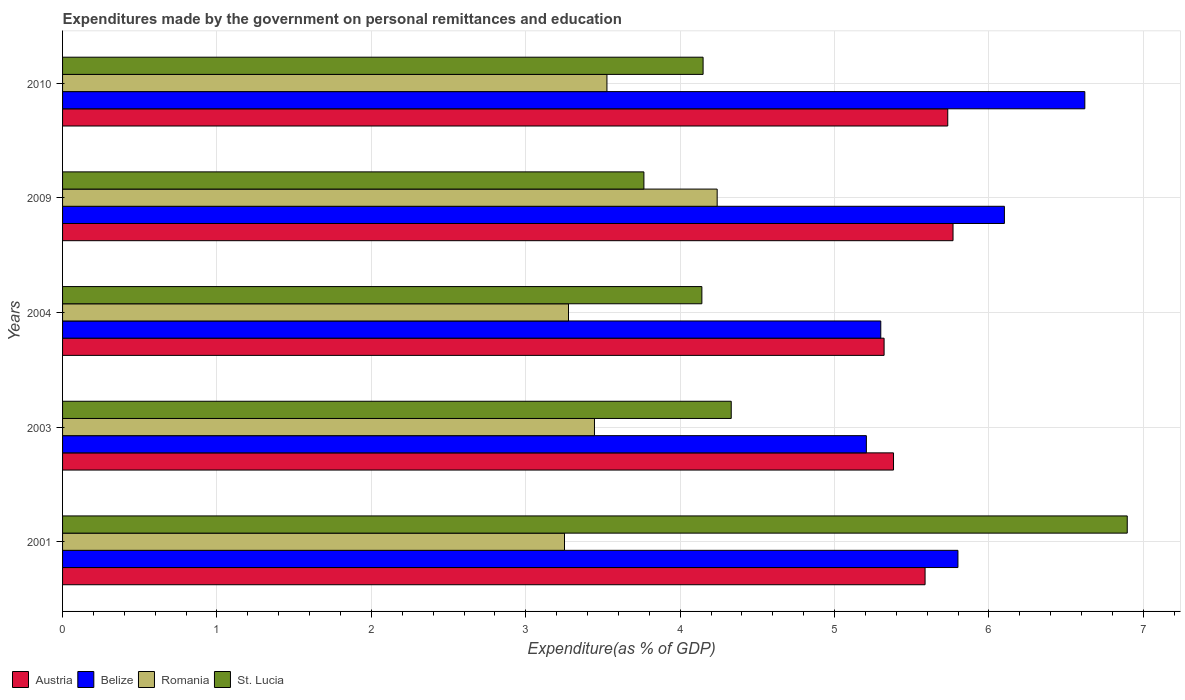How many groups of bars are there?
Make the answer very short. 5. Are the number of bars per tick equal to the number of legend labels?
Your answer should be very brief. Yes. How many bars are there on the 1st tick from the top?
Offer a terse response. 4. In how many cases, is the number of bars for a given year not equal to the number of legend labels?
Give a very brief answer. 0. What is the expenditures made by the government on personal remittances and education in Austria in 2010?
Ensure brevity in your answer.  5.73. Across all years, what is the maximum expenditures made by the government on personal remittances and education in St. Lucia?
Provide a short and direct response. 6.9. Across all years, what is the minimum expenditures made by the government on personal remittances and education in Romania?
Offer a terse response. 3.25. In which year was the expenditures made by the government on personal remittances and education in St. Lucia maximum?
Ensure brevity in your answer.  2001. What is the total expenditures made by the government on personal remittances and education in St. Lucia in the graph?
Keep it short and to the point. 23.28. What is the difference between the expenditures made by the government on personal remittances and education in Romania in 2004 and that in 2010?
Make the answer very short. -0.25. What is the difference between the expenditures made by the government on personal remittances and education in Austria in 2009 and the expenditures made by the government on personal remittances and education in Romania in 2001?
Offer a terse response. 2.52. What is the average expenditures made by the government on personal remittances and education in Romania per year?
Ensure brevity in your answer.  3.55. In the year 2001, what is the difference between the expenditures made by the government on personal remittances and education in Belize and expenditures made by the government on personal remittances and education in Romania?
Your response must be concise. 2.55. In how many years, is the expenditures made by the government on personal remittances and education in Belize greater than 1.6 %?
Offer a terse response. 5. What is the ratio of the expenditures made by the government on personal remittances and education in Belize in 2001 to that in 2003?
Your answer should be compact. 1.11. Is the difference between the expenditures made by the government on personal remittances and education in Belize in 2001 and 2009 greater than the difference between the expenditures made by the government on personal remittances and education in Romania in 2001 and 2009?
Make the answer very short. Yes. What is the difference between the highest and the second highest expenditures made by the government on personal remittances and education in St. Lucia?
Your answer should be compact. 2.56. What is the difference between the highest and the lowest expenditures made by the government on personal remittances and education in St. Lucia?
Give a very brief answer. 3.13. What does the 1st bar from the bottom in 2001 represents?
Your answer should be compact. Austria. Is it the case that in every year, the sum of the expenditures made by the government on personal remittances and education in Belize and expenditures made by the government on personal remittances and education in Romania is greater than the expenditures made by the government on personal remittances and education in Austria?
Your response must be concise. Yes. How many years are there in the graph?
Offer a terse response. 5. Are the values on the major ticks of X-axis written in scientific E-notation?
Give a very brief answer. No. Does the graph contain any zero values?
Keep it short and to the point. No. Does the graph contain grids?
Keep it short and to the point. Yes. How many legend labels are there?
Keep it short and to the point. 4. How are the legend labels stacked?
Your answer should be compact. Horizontal. What is the title of the graph?
Provide a succinct answer. Expenditures made by the government on personal remittances and education. Does "Luxembourg" appear as one of the legend labels in the graph?
Provide a succinct answer. No. What is the label or title of the X-axis?
Give a very brief answer. Expenditure(as % of GDP). What is the Expenditure(as % of GDP) in Austria in 2001?
Your answer should be compact. 5.59. What is the Expenditure(as % of GDP) in Belize in 2001?
Make the answer very short. 5.8. What is the Expenditure(as % of GDP) in Romania in 2001?
Your answer should be compact. 3.25. What is the Expenditure(as % of GDP) in St. Lucia in 2001?
Offer a very short reply. 6.9. What is the Expenditure(as % of GDP) in Austria in 2003?
Offer a terse response. 5.38. What is the Expenditure(as % of GDP) of Belize in 2003?
Provide a succinct answer. 5.21. What is the Expenditure(as % of GDP) of Romania in 2003?
Offer a very short reply. 3.45. What is the Expenditure(as % of GDP) of St. Lucia in 2003?
Offer a very short reply. 4.33. What is the Expenditure(as % of GDP) in Austria in 2004?
Offer a terse response. 5.32. What is the Expenditure(as % of GDP) in Belize in 2004?
Offer a very short reply. 5.3. What is the Expenditure(as % of GDP) of Romania in 2004?
Offer a terse response. 3.28. What is the Expenditure(as % of GDP) in St. Lucia in 2004?
Provide a short and direct response. 4.14. What is the Expenditure(as % of GDP) of Austria in 2009?
Provide a short and direct response. 5.77. What is the Expenditure(as % of GDP) of Belize in 2009?
Your response must be concise. 6.1. What is the Expenditure(as % of GDP) of Romania in 2009?
Ensure brevity in your answer.  4.24. What is the Expenditure(as % of GDP) in St. Lucia in 2009?
Provide a succinct answer. 3.77. What is the Expenditure(as % of GDP) in Austria in 2010?
Give a very brief answer. 5.73. What is the Expenditure(as % of GDP) in Belize in 2010?
Give a very brief answer. 6.62. What is the Expenditure(as % of GDP) of Romania in 2010?
Offer a very short reply. 3.53. What is the Expenditure(as % of GDP) of St. Lucia in 2010?
Give a very brief answer. 4.15. Across all years, what is the maximum Expenditure(as % of GDP) of Austria?
Offer a very short reply. 5.77. Across all years, what is the maximum Expenditure(as % of GDP) of Belize?
Provide a succinct answer. 6.62. Across all years, what is the maximum Expenditure(as % of GDP) in Romania?
Provide a short and direct response. 4.24. Across all years, what is the maximum Expenditure(as % of GDP) of St. Lucia?
Keep it short and to the point. 6.9. Across all years, what is the minimum Expenditure(as % of GDP) of Austria?
Your answer should be compact. 5.32. Across all years, what is the minimum Expenditure(as % of GDP) of Belize?
Keep it short and to the point. 5.21. Across all years, what is the minimum Expenditure(as % of GDP) in Romania?
Provide a succinct answer. 3.25. Across all years, what is the minimum Expenditure(as % of GDP) of St. Lucia?
Keep it short and to the point. 3.77. What is the total Expenditure(as % of GDP) of Austria in the graph?
Your answer should be compact. 27.79. What is the total Expenditure(as % of GDP) of Belize in the graph?
Make the answer very short. 29.03. What is the total Expenditure(as % of GDP) in Romania in the graph?
Your answer should be very brief. 17.74. What is the total Expenditure(as % of GDP) of St. Lucia in the graph?
Your response must be concise. 23.28. What is the difference between the Expenditure(as % of GDP) of Austria in 2001 and that in 2003?
Offer a very short reply. 0.2. What is the difference between the Expenditure(as % of GDP) of Belize in 2001 and that in 2003?
Offer a terse response. 0.59. What is the difference between the Expenditure(as % of GDP) of Romania in 2001 and that in 2003?
Offer a terse response. -0.19. What is the difference between the Expenditure(as % of GDP) in St. Lucia in 2001 and that in 2003?
Offer a terse response. 2.56. What is the difference between the Expenditure(as % of GDP) of Austria in 2001 and that in 2004?
Your answer should be compact. 0.27. What is the difference between the Expenditure(as % of GDP) in Belize in 2001 and that in 2004?
Keep it short and to the point. 0.5. What is the difference between the Expenditure(as % of GDP) of Romania in 2001 and that in 2004?
Your answer should be very brief. -0.03. What is the difference between the Expenditure(as % of GDP) of St. Lucia in 2001 and that in 2004?
Ensure brevity in your answer.  2.76. What is the difference between the Expenditure(as % of GDP) in Austria in 2001 and that in 2009?
Give a very brief answer. -0.18. What is the difference between the Expenditure(as % of GDP) of Belize in 2001 and that in 2009?
Your response must be concise. -0.3. What is the difference between the Expenditure(as % of GDP) of Romania in 2001 and that in 2009?
Offer a terse response. -0.99. What is the difference between the Expenditure(as % of GDP) in St. Lucia in 2001 and that in 2009?
Provide a succinct answer. 3.13. What is the difference between the Expenditure(as % of GDP) of Austria in 2001 and that in 2010?
Provide a succinct answer. -0.15. What is the difference between the Expenditure(as % of GDP) in Belize in 2001 and that in 2010?
Provide a succinct answer. -0.82. What is the difference between the Expenditure(as % of GDP) in Romania in 2001 and that in 2010?
Make the answer very short. -0.27. What is the difference between the Expenditure(as % of GDP) of St. Lucia in 2001 and that in 2010?
Offer a terse response. 2.75. What is the difference between the Expenditure(as % of GDP) in Austria in 2003 and that in 2004?
Give a very brief answer. 0.06. What is the difference between the Expenditure(as % of GDP) in Belize in 2003 and that in 2004?
Offer a very short reply. -0.09. What is the difference between the Expenditure(as % of GDP) of Romania in 2003 and that in 2004?
Give a very brief answer. 0.17. What is the difference between the Expenditure(as % of GDP) in St. Lucia in 2003 and that in 2004?
Offer a very short reply. 0.19. What is the difference between the Expenditure(as % of GDP) in Austria in 2003 and that in 2009?
Offer a very short reply. -0.39. What is the difference between the Expenditure(as % of GDP) of Belize in 2003 and that in 2009?
Your answer should be compact. -0.89. What is the difference between the Expenditure(as % of GDP) of Romania in 2003 and that in 2009?
Keep it short and to the point. -0.79. What is the difference between the Expenditure(as % of GDP) in St. Lucia in 2003 and that in 2009?
Your response must be concise. 0.57. What is the difference between the Expenditure(as % of GDP) of Austria in 2003 and that in 2010?
Give a very brief answer. -0.35. What is the difference between the Expenditure(as % of GDP) of Belize in 2003 and that in 2010?
Provide a short and direct response. -1.41. What is the difference between the Expenditure(as % of GDP) in Romania in 2003 and that in 2010?
Offer a terse response. -0.08. What is the difference between the Expenditure(as % of GDP) of St. Lucia in 2003 and that in 2010?
Your response must be concise. 0.18. What is the difference between the Expenditure(as % of GDP) of Austria in 2004 and that in 2009?
Offer a terse response. -0.45. What is the difference between the Expenditure(as % of GDP) of Belize in 2004 and that in 2009?
Provide a short and direct response. -0.8. What is the difference between the Expenditure(as % of GDP) of Romania in 2004 and that in 2009?
Offer a very short reply. -0.96. What is the difference between the Expenditure(as % of GDP) in St. Lucia in 2004 and that in 2009?
Your answer should be very brief. 0.38. What is the difference between the Expenditure(as % of GDP) in Austria in 2004 and that in 2010?
Offer a very short reply. -0.41. What is the difference between the Expenditure(as % of GDP) of Belize in 2004 and that in 2010?
Provide a short and direct response. -1.32. What is the difference between the Expenditure(as % of GDP) in Romania in 2004 and that in 2010?
Offer a very short reply. -0.25. What is the difference between the Expenditure(as % of GDP) in St. Lucia in 2004 and that in 2010?
Make the answer very short. -0.01. What is the difference between the Expenditure(as % of GDP) in Austria in 2009 and that in 2010?
Provide a succinct answer. 0.03. What is the difference between the Expenditure(as % of GDP) of Belize in 2009 and that in 2010?
Ensure brevity in your answer.  -0.52. What is the difference between the Expenditure(as % of GDP) of Romania in 2009 and that in 2010?
Your response must be concise. 0.71. What is the difference between the Expenditure(as % of GDP) in St. Lucia in 2009 and that in 2010?
Keep it short and to the point. -0.38. What is the difference between the Expenditure(as % of GDP) of Austria in 2001 and the Expenditure(as % of GDP) of Belize in 2003?
Keep it short and to the point. 0.38. What is the difference between the Expenditure(as % of GDP) in Austria in 2001 and the Expenditure(as % of GDP) in Romania in 2003?
Ensure brevity in your answer.  2.14. What is the difference between the Expenditure(as % of GDP) of Austria in 2001 and the Expenditure(as % of GDP) of St. Lucia in 2003?
Keep it short and to the point. 1.26. What is the difference between the Expenditure(as % of GDP) of Belize in 2001 and the Expenditure(as % of GDP) of Romania in 2003?
Offer a terse response. 2.35. What is the difference between the Expenditure(as % of GDP) in Belize in 2001 and the Expenditure(as % of GDP) in St. Lucia in 2003?
Provide a short and direct response. 1.47. What is the difference between the Expenditure(as % of GDP) of Romania in 2001 and the Expenditure(as % of GDP) of St. Lucia in 2003?
Make the answer very short. -1.08. What is the difference between the Expenditure(as % of GDP) of Austria in 2001 and the Expenditure(as % of GDP) of Belize in 2004?
Give a very brief answer. 0.29. What is the difference between the Expenditure(as % of GDP) of Austria in 2001 and the Expenditure(as % of GDP) of Romania in 2004?
Keep it short and to the point. 2.31. What is the difference between the Expenditure(as % of GDP) of Austria in 2001 and the Expenditure(as % of GDP) of St. Lucia in 2004?
Your answer should be very brief. 1.45. What is the difference between the Expenditure(as % of GDP) of Belize in 2001 and the Expenditure(as % of GDP) of Romania in 2004?
Your answer should be compact. 2.52. What is the difference between the Expenditure(as % of GDP) in Belize in 2001 and the Expenditure(as % of GDP) in St. Lucia in 2004?
Your answer should be very brief. 1.66. What is the difference between the Expenditure(as % of GDP) in Romania in 2001 and the Expenditure(as % of GDP) in St. Lucia in 2004?
Make the answer very short. -0.89. What is the difference between the Expenditure(as % of GDP) in Austria in 2001 and the Expenditure(as % of GDP) in Belize in 2009?
Ensure brevity in your answer.  -0.51. What is the difference between the Expenditure(as % of GDP) in Austria in 2001 and the Expenditure(as % of GDP) in Romania in 2009?
Offer a terse response. 1.35. What is the difference between the Expenditure(as % of GDP) of Austria in 2001 and the Expenditure(as % of GDP) of St. Lucia in 2009?
Offer a terse response. 1.82. What is the difference between the Expenditure(as % of GDP) of Belize in 2001 and the Expenditure(as % of GDP) of Romania in 2009?
Your response must be concise. 1.56. What is the difference between the Expenditure(as % of GDP) of Belize in 2001 and the Expenditure(as % of GDP) of St. Lucia in 2009?
Provide a succinct answer. 2.03. What is the difference between the Expenditure(as % of GDP) in Romania in 2001 and the Expenditure(as % of GDP) in St. Lucia in 2009?
Keep it short and to the point. -0.51. What is the difference between the Expenditure(as % of GDP) in Austria in 2001 and the Expenditure(as % of GDP) in Belize in 2010?
Give a very brief answer. -1.03. What is the difference between the Expenditure(as % of GDP) of Austria in 2001 and the Expenditure(as % of GDP) of Romania in 2010?
Your response must be concise. 2.06. What is the difference between the Expenditure(as % of GDP) of Austria in 2001 and the Expenditure(as % of GDP) of St. Lucia in 2010?
Your answer should be very brief. 1.44. What is the difference between the Expenditure(as % of GDP) in Belize in 2001 and the Expenditure(as % of GDP) in Romania in 2010?
Your answer should be compact. 2.27. What is the difference between the Expenditure(as % of GDP) in Belize in 2001 and the Expenditure(as % of GDP) in St. Lucia in 2010?
Your answer should be very brief. 1.65. What is the difference between the Expenditure(as % of GDP) in Romania in 2001 and the Expenditure(as % of GDP) in St. Lucia in 2010?
Make the answer very short. -0.9. What is the difference between the Expenditure(as % of GDP) in Austria in 2003 and the Expenditure(as % of GDP) in Belize in 2004?
Offer a very short reply. 0.08. What is the difference between the Expenditure(as % of GDP) in Austria in 2003 and the Expenditure(as % of GDP) in Romania in 2004?
Your answer should be compact. 2.1. What is the difference between the Expenditure(as % of GDP) of Austria in 2003 and the Expenditure(as % of GDP) of St. Lucia in 2004?
Offer a very short reply. 1.24. What is the difference between the Expenditure(as % of GDP) of Belize in 2003 and the Expenditure(as % of GDP) of Romania in 2004?
Make the answer very short. 1.93. What is the difference between the Expenditure(as % of GDP) in Belize in 2003 and the Expenditure(as % of GDP) in St. Lucia in 2004?
Ensure brevity in your answer.  1.07. What is the difference between the Expenditure(as % of GDP) in Romania in 2003 and the Expenditure(as % of GDP) in St. Lucia in 2004?
Offer a very short reply. -0.7. What is the difference between the Expenditure(as % of GDP) in Austria in 2003 and the Expenditure(as % of GDP) in Belize in 2009?
Your answer should be very brief. -0.72. What is the difference between the Expenditure(as % of GDP) in Austria in 2003 and the Expenditure(as % of GDP) in Romania in 2009?
Offer a very short reply. 1.14. What is the difference between the Expenditure(as % of GDP) in Austria in 2003 and the Expenditure(as % of GDP) in St. Lucia in 2009?
Give a very brief answer. 1.62. What is the difference between the Expenditure(as % of GDP) of Belize in 2003 and the Expenditure(as % of GDP) of Romania in 2009?
Ensure brevity in your answer.  0.97. What is the difference between the Expenditure(as % of GDP) of Belize in 2003 and the Expenditure(as % of GDP) of St. Lucia in 2009?
Your answer should be compact. 1.44. What is the difference between the Expenditure(as % of GDP) in Romania in 2003 and the Expenditure(as % of GDP) in St. Lucia in 2009?
Ensure brevity in your answer.  -0.32. What is the difference between the Expenditure(as % of GDP) of Austria in 2003 and the Expenditure(as % of GDP) of Belize in 2010?
Give a very brief answer. -1.24. What is the difference between the Expenditure(as % of GDP) of Austria in 2003 and the Expenditure(as % of GDP) of Romania in 2010?
Make the answer very short. 1.86. What is the difference between the Expenditure(as % of GDP) in Austria in 2003 and the Expenditure(as % of GDP) in St. Lucia in 2010?
Make the answer very short. 1.23. What is the difference between the Expenditure(as % of GDP) in Belize in 2003 and the Expenditure(as % of GDP) in Romania in 2010?
Offer a very short reply. 1.68. What is the difference between the Expenditure(as % of GDP) of Belize in 2003 and the Expenditure(as % of GDP) of St. Lucia in 2010?
Provide a succinct answer. 1.06. What is the difference between the Expenditure(as % of GDP) of Romania in 2003 and the Expenditure(as % of GDP) of St. Lucia in 2010?
Your answer should be compact. -0.7. What is the difference between the Expenditure(as % of GDP) of Austria in 2004 and the Expenditure(as % of GDP) of Belize in 2009?
Your response must be concise. -0.78. What is the difference between the Expenditure(as % of GDP) of Austria in 2004 and the Expenditure(as % of GDP) of Romania in 2009?
Your answer should be compact. 1.08. What is the difference between the Expenditure(as % of GDP) of Austria in 2004 and the Expenditure(as % of GDP) of St. Lucia in 2009?
Provide a succinct answer. 1.56. What is the difference between the Expenditure(as % of GDP) of Belize in 2004 and the Expenditure(as % of GDP) of Romania in 2009?
Offer a very short reply. 1.06. What is the difference between the Expenditure(as % of GDP) in Belize in 2004 and the Expenditure(as % of GDP) in St. Lucia in 2009?
Provide a short and direct response. 1.53. What is the difference between the Expenditure(as % of GDP) in Romania in 2004 and the Expenditure(as % of GDP) in St. Lucia in 2009?
Offer a terse response. -0.49. What is the difference between the Expenditure(as % of GDP) of Austria in 2004 and the Expenditure(as % of GDP) of Belize in 2010?
Offer a very short reply. -1.3. What is the difference between the Expenditure(as % of GDP) of Austria in 2004 and the Expenditure(as % of GDP) of Romania in 2010?
Offer a terse response. 1.8. What is the difference between the Expenditure(as % of GDP) in Austria in 2004 and the Expenditure(as % of GDP) in St. Lucia in 2010?
Provide a short and direct response. 1.17. What is the difference between the Expenditure(as % of GDP) in Belize in 2004 and the Expenditure(as % of GDP) in Romania in 2010?
Provide a short and direct response. 1.77. What is the difference between the Expenditure(as % of GDP) in Belize in 2004 and the Expenditure(as % of GDP) in St. Lucia in 2010?
Provide a short and direct response. 1.15. What is the difference between the Expenditure(as % of GDP) in Romania in 2004 and the Expenditure(as % of GDP) in St. Lucia in 2010?
Provide a short and direct response. -0.87. What is the difference between the Expenditure(as % of GDP) of Austria in 2009 and the Expenditure(as % of GDP) of Belize in 2010?
Offer a very short reply. -0.85. What is the difference between the Expenditure(as % of GDP) of Austria in 2009 and the Expenditure(as % of GDP) of Romania in 2010?
Provide a succinct answer. 2.24. What is the difference between the Expenditure(as % of GDP) in Austria in 2009 and the Expenditure(as % of GDP) in St. Lucia in 2010?
Your answer should be very brief. 1.62. What is the difference between the Expenditure(as % of GDP) in Belize in 2009 and the Expenditure(as % of GDP) in Romania in 2010?
Offer a very short reply. 2.57. What is the difference between the Expenditure(as % of GDP) of Belize in 2009 and the Expenditure(as % of GDP) of St. Lucia in 2010?
Provide a short and direct response. 1.95. What is the difference between the Expenditure(as % of GDP) of Romania in 2009 and the Expenditure(as % of GDP) of St. Lucia in 2010?
Offer a terse response. 0.09. What is the average Expenditure(as % of GDP) of Austria per year?
Your answer should be compact. 5.56. What is the average Expenditure(as % of GDP) in Belize per year?
Your response must be concise. 5.81. What is the average Expenditure(as % of GDP) of Romania per year?
Your answer should be very brief. 3.55. What is the average Expenditure(as % of GDP) in St. Lucia per year?
Offer a terse response. 4.66. In the year 2001, what is the difference between the Expenditure(as % of GDP) of Austria and Expenditure(as % of GDP) of Belize?
Your answer should be very brief. -0.21. In the year 2001, what is the difference between the Expenditure(as % of GDP) of Austria and Expenditure(as % of GDP) of Romania?
Your answer should be very brief. 2.34. In the year 2001, what is the difference between the Expenditure(as % of GDP) in Austria and Expenditure(as % of GDP) in St. Lucia?
Ensure brevity in your answer.  -1.31. In the year 2001, what is the difference between the Expenditure(as % of GDP) of Belize and Expenditure(as % of GDP) of Romania?
Provide a short and direct response. 2.55. In the year 2001, what is the difference between the Expenditure(as % of GDP) in Belize and Expenditure(as % of GDP) in St. Lucia?
Your response must be concise. -1.1. In the year 2001, what is the difference between the Expenditure(as % of GDP) of Romania and Expenditure(as % of GDP) of St. Lucia?
Your answer should be very brief. -3.64. In the year 2003, what is the difference between the Expenditure(as % of GDP) of Austria and Expenditure(as % of GDP) of Belize?
Your response must be concise. 0.18. In the year 2003, what is the difference between the Expenditure(as % of GDP) of Austria and Expenditure(as % of GDP) of Romania?
Your response must be concise. 1.94. In the year 2003, what is the difference between the Expenditure(as % of GDP) in Austria and Expenditure(as % of GDP) in St. Lucia?
Give a very brief answer. 1.05. In the year 2003, what is the difference between the Expenditure(as % of GDP) in Belize and Expenditure(as % of GDP) in Romania?
Ensure brevity in your answer.  1.76. In the year 2003, what is the difference between the Expenditure(as % of GDP) in Belize and Expenditure(as % of GDP) in St. Lucia?
Give a very brief answer. 0.88. In the year 2003, what is the difference between the Expenditure(as % of GDP) of Romania and Expenditure(as % of GDP) of St. Lucia?
Give a very brief answer. -0.89. In the year 2004, what is the difference between the Expenditure(as % of GDP) of Austria and Expenditure(as % of GDP) of Belize?
Your answer should be compact. 0.02. In the year 2004, what is the difference between the Expenditure(as % of GDP) in Austria and Expenditure(as % of GDP) in Romania?
Your answer should be very brief. 2.04. In the year 2004, what is the difference between the Expenditure(as % of GDP) of Austria and Expenditure(as % of GDP) of St. Lucia?
Provide a succinct answer. 1.18. In the year 2004, what is the difference between the Expenditure(as % of GDP) in Belize and Expenditure(as % of GDP) in Romania?
Ensure brevity in your answer.  2.02. In the year 2004, what is the difference between the Expenditure(as % of GDP) of Belize and Expenditure(as % of GDP) of St. Lucia?
Ensure brevity in your answer.  1.16. In the year 2004, what is the difference between the Expenditure(as % of GDP) in Romania and Expenditure(as % of GDP) in St. Lucia?
Your answer should be compact. -0.86. In the year 2009, what is the difference between the Expenditure(as % of GDP) in Austria and Expenditure(as % of GDP) in Belize?
Your answer should be compact. -0.33. In the year 2009, what is the difference between the Expenditure(as % of GDP) of Austria and Expenditure(as % of GDP) of Romania?
Provide a short and direct response. 1.53. In the year 2009, what is the difference between the Expenditure(as % of GDP) of Austria and Expenditure(as % of GDP) of St. Lucia?
Provide a short and direct response. 2. In the year 2009, what is the difference between the Expenditure(as % of GDP) in Belize and Expenditure(as % of GDP) in Romania?
Make the answer very short. 1.86. In the year 2009, what is the difference between the Expenditure(as % of GDP) of Belize and Expenditure(as % of GDP) of St. Lucia?
Provide a succinct answer. 2.33. In the year 2009, what is the difference between the Expenditure(as % of GDP) of Romania and Expenditure(as % of GDP) of St. Lucia?
Your response must be concise. 0.47. In the year 2010, what is the difference between the Expenditure(as % of GDP) in Austria and Expenditure(as % of GDP) in Belize?
Ensure brevity in your answer.  -0.89. In the year 2010, what is the difference between the Expenditure(as % of GDP) of Austria and Expenditure(as % of GDP) of Romania?
Make the answer very short. 2.21. In the year 2010, what is the difference between the Expenditure(as % of GDP) in Austria and Expenditure(as % of GDP) in St. Lucia?
Offer a very short reply. 1.58. In the year 2010, what is the difference between the Expenditure(as % of GDP) in Belize and Expenditure(as % of GDP) in Romania?
Keep it short and to the point. 3.1. In the year 2010, what is the difference between the Expenditure(as % of GDP) of Belize and Expenditure(as % of GDP) of St. Lucia?
Make the answer very short. 2.47. In the year 2010, what is the difference between the Expenditure(as % of GDP) in Romania and Expenditure(as % of GDP) in St. Lucia?
Make the answer very short. -0.62. What is the ratio of the Expenditure(as % of GDP) in Austria in 2001 to that in 2003?
Provide a succinct answer. 1.04. What is the ratio of the Expenditure(as % of GDP) in Belize in 2001 to that in 2003?
Offer a terse response. 1.11. What is the ratio of the Expenditure(as % of GDP) in Romania in 2001 to that in 2003?
Give a very brief answer. 0.94. What is the ratio of the Expenditure(as % of GDP) of St. Lucia in 2001 to that in 2003?
Offer a terse response. 1.59. What is the ratio of the Expenditure(as % of GDP) of Austria in 2001 to that in 2004?
Make the answer very short. 1.05. What is the ratio of the Expenditure(as % of GDP) of Belize in 2001 to that in 2004?
Give a very brief answer. 1.09. What is the ratio of the Expenditure(as % of GDP) in Romania in 2001 to that in 2004?
Your response must be concise. 0.99. What is the ratio of the Expenditure(as % of GDP) in St. Lucia in 2001 to that in 2004?
Provide a succinct answer. 1.67. What is the ratio of the Expenditure(as % of GDP) of Austria in 2001 to that in 2009?
Offer a terse response. 0.97. What is the ratio of the Expenditure(as % of GDP) of Belize in 2001 to that in 2009?
Keep it short and to the point. 0.95. What is the ratio of the Expenditure(as % of GDP) in Romania in 2001 to that in 2009?
Give a very brief answer. 0.77. What is the ratio of the Expenditure(as % of GDP) of St. Lucia in 2001 to that in 2009?
Keep it short and to the point. 1.83. What is the ratio of the Expenditure(as % of GDP) in Austria in 2001 to that in 2010?
Your answer should be compact. 0.97. What is the ratio of the Expenditure(as % of GDP) in Belize in 2001 to that in 2010?
Ensure brevity in your answer.  0.88. What is the ratio of the Expenditure(as % of GDP) of Romania in 2001 to that in 2010?
Make the answer very short. 0.92. What is the ratio of the Expenditure(as % of GDP) in St. Lucia in 2001 to that in 2010?
Offer a very short reply. 1.66. What is the ratio of the Expenditure(as % of GDP) in Austria in 2003 to that in 2004?
Ensure brevity in your answer.  1.01. What is the ratio of the Expenditure(as % of GDP) in Belize in 2003 to that in 2004?
Your answer should be compact. 0.98. What is the ratio of the Expenditure(as % of GDP) of Romania in 2003 to that in 2004?
Your answer should be very brief. 1.05. What is the ratio of the Expenditure(as % of GDP) in St. Lucia in 2003 to that in 2004?
Your answer should be very brief. 1.05. What is the ratio of the Expenditure(as % of GDP) of Austria in 2003 to that in 2009?
Give a very brief answer. 0.93. What is the ratio of the Expenditure(as % of GDP) in Belize in 2003 to that in 2009?
Ensure brevity in your answer.  0.85. What is the ratio of the Expenditure(as % of GDP) in Romania in 2003 to that in 2009?
Your response must be concise. 0.81. What is the ratio of the Expenditure(as % of GDP) of St. Lucia in 2003 to that in 2009?
Keep it short and to the point. 1.15. What is the ratio of the Expenditure(as % of GDP) in Austria in 2003 to that in 2010?
Ensure brevity in your answer.  0.94. What is the ratio of the Expenditure(as % of GDP) in Belize in 2003 to that in 2010?
Your answer should be very brief. 0.79. What is the ratio of the Expenditure(as % of GDP) of Romania in 2003 to that in 2010?
Ensure brevity in your answer.  0.98. What is the ratio of the Expenditure(as % of GDP) in St. Lucia in 2003 to that in 2010?
Your answer should be compact. 1.04. What is the ratio of the Expenditure(as % of GDP) of Austria in 2004 to that in 2009?
Offer a terse response. 0.92. What is the ratio of the Expenditure(as % of GDP) in Belize in 2004 to that in 2009?
Your answer should be compact. 0.87. What is the ratio of the Expenditure(as % of GDP) of Romania in 2004 to that in 2009?
Your response must be concise. 0.77. What is the ratio of the Expenditure(as % of GDP) in St. Lucia in 2004 to that in 2009?
Your answer should be very brief. 1.1. What is the ratio of the Expenditure(as % of GDP) in Austria in 2004 to that in 2010?
Your response must be concise. 0.93. What is the ratio of the Expenditure(as % of GDP) in Belize in 2004 to that in 2010?
Provide a succinct answer. 0.8. What is the ratio of the Expenditure(as % of GDP) in Romania in 2004 to that in 2010?
Provide a succinct answer. 0.93. What is the ratio of the Expenditure(as % of GDP) in Belize in 2009 to that in 2010?
Offer a very short reply. 0.92. What is the ratio of the Expenditure(as % of GDP) of Romania in 2009 to that in 2010?
Provide a succinct answer. 1.2. What is the ratio of the Expenditure(as % of GDP) in St. Lucia in 2009 to that in 2010?
Your answer should be very brief. 0.91. What is the difference between the highest and the second highest Expenditure(as % of GDP) of Austria?
Keep it short and to the point. 0.03. What is the difference between the highest and the second highest Expenditure(as % of GDP) of Belize?
Provide a short and direct response. 0.52. What is the difference between the highest and the second highest Expenditure(as % of GDP) of Romania?
Offer a very short reply. 0.71. What is the difference between the highest and the second highest Expenditure(as % of GDP) in St. Lucia?
Make the answer very short. 2.56. What is the difference between the highest and the lowest Expenditure(as % of GDP) in Austria?
Offer a terse response. 0.45. What is the difference between the highest and the lowest Expenditure(as % of GDP) of Belize?
Your answer should be compact. 1.41. What is the difference between the highest and the lowest Expenditure(as % of GDP) in Romania?
Provide a short and direct response. 0.99. What is the difference between the highest and the lowest Expenditure(as % of GDP) of St. Lucia?
Provide a short and direct response. 3.13. 